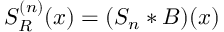<formula> <loc_0><loc_0><loc_500><loc_500>S _ { R } ^ { ( n ) } ( x ) = ( S _ { n } * B ) ( x )</formula> 